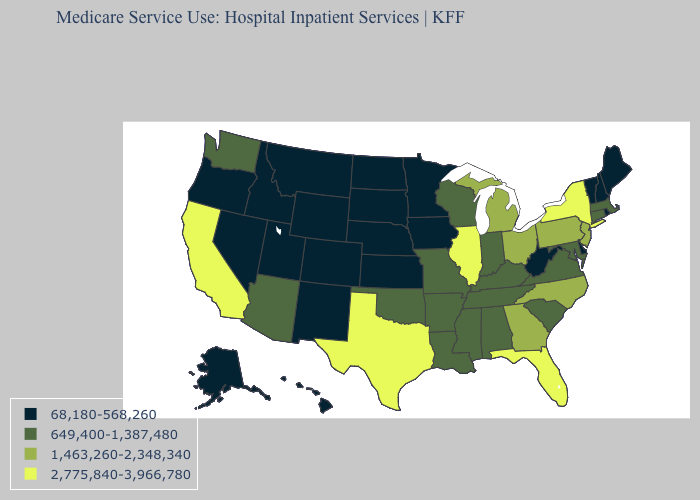What is the highest value in the USA?
Write a very short answer. 2,775,840-3,966,780. Name the states that have a value in the range 2,775,840-3,966,780?
Short answer required. California, Florida, Illinois, New York, Texas. What is the value of Alaska?
Short answer required. 68,180-568,260. Which states have the lowest value in the South?
Short answer required. Delaware, West Virginia. Does Wyoming have the same value as Rhode Island?
Be succinct. Yes. Name the states that have a value in the range 2,775,840-3,966,780?
Be succinct. California, Florida, Illinois, New York, Texas. What is the lowest value in the USA?
Short answer required. 68,180-568,260. What is the lowest value in the USA?
Keep it brief. 68,180-568,260. What is the lowest value in the USA?
Short answer required. 68,180-568,260. Among the states that border New York , which have the highest value?
Short answer required. New Jersey, Pennsylvania. What is the value of Kansas?
Write a very short answer. 68,180-568,260. Among the states that border Illinois , which have the highest value?
Concise answer only. Indiana, Kentucky, Missouri, Wisconsin. Does Delaware have the same value as Kansas?
Give a very brief answer. Yes. Name the states that have a value in the range 2,775,840-3,966,780?
Short answer required. California, Florida, Illinois, New York, Texas. Does South Carolina have the lowest value in the USA?
Short answer required. No. 